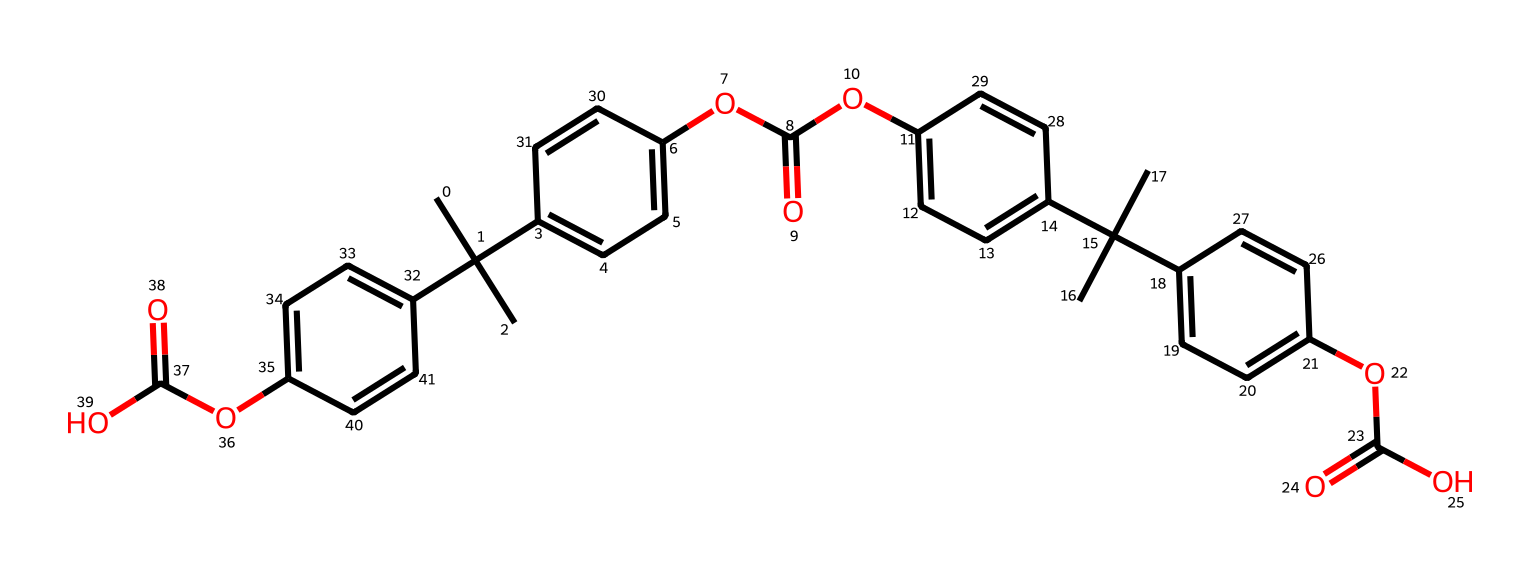How many carbon atoms are present in the structure? By examining the SMILES representation, we identify each "C" as a carbon atom. Counting through the structure, we find a total of 30 occurrences of "C".
Answer: 30 What functional groups are present in this molecule? The structure contains ester groups represented by "OC(=O)", indicating the presence of carboxylate functional groups, which are also connected to aromatic rings. We identify at least three such groups.
Answer: ester What is the molecular formula of this polymer? From the molecular structure, we can deduce the counts of each atom type based on the SMILES parsing. After thorough analysis, we obtain C30H36O6 as the molecular formula.
Answer: C30H36O6 What type of polymer structure is indicated in this SMILES? The repeated ester connections in the backbone and cross-linking indicate it is a thermoplastic polyester. This identification is based on the combination of aromatic rings and ester groups common in such materials.
Answer: thermoplastic polyester How many distinct aromatic rings can be identified in this polymer? A careful examination of the structure shows three distinct aromatic rings present, as indicated by the presence of "c" and the connectivity around those "c" indicators in the SMILES.
Answer: 3 Is this polymer more likely to be rigid or flexible? The presence of multiple aromatic rings suggests rigidity due to their planar structure and bond characteristics, which limit rotational freedom, typical for aromatic polymers.
Answer: rigid 